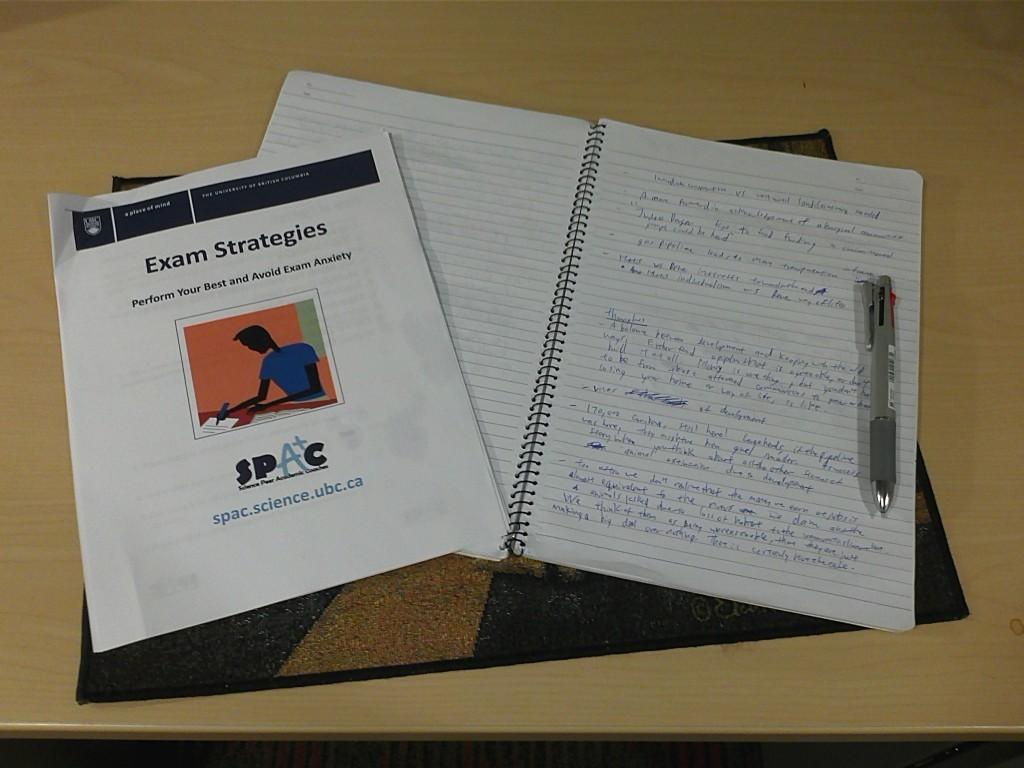What is the title of the paper to the left?
Ensure brevity in your answer.  Exam strategies. What is the subject of the pamphlet?
Make the answer very short. Exam strategies. 